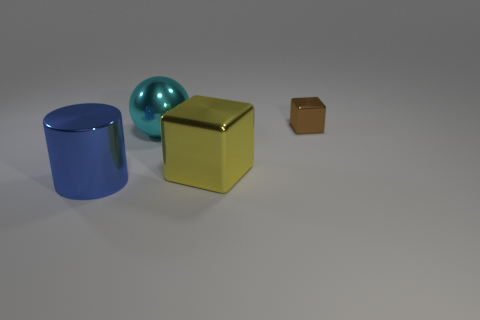How many big objects are either yellow objects or balls?
Provide a short and direct response. 2. Does the metallic cube to the left of the brown thing have the same size as the brown block?
Offer a very short reply. No. How many other things are there of the same color as the cylinder?
Ensure brevity in your answer.  0. What material is the tiny cube?
Give a very brief answer. Metal. What number of objects are metal cubes in front of the tiny thing or yellow metal cubes?
Keep it short and to the point. 1. Are there any cyan objects that have the same size as the metal ball?
Your answer should be compact. No. What number of things are both on the right side of the large sphere and in front of the large sphere?
Keep it short and to the point. 1. There is a big yellow block; how many cyan metallic things are in front of it?
Keep it short and to the point. 0. Are there any other things that have the same shape as the big yellow object?
Ensure brevity in your answer.  Yes. There is a small brown thing; is it the same shape as the big object that is to the right of the cyan shiny ball?
Make the answer very short. Yes. 